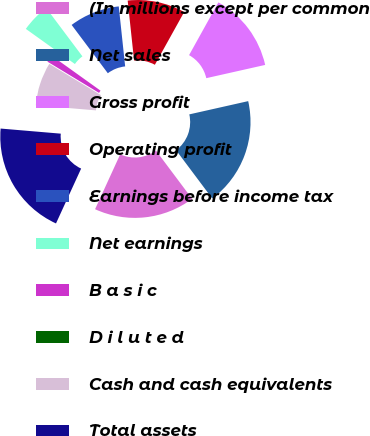<chart> <loc_0><loc_0><loc_500><loc_500><pie_chart><fcel>(In millions except per common<fcel>Net sales<fcel>Gross profit<fcel>Operating profit<fcel>Earnings before income tax<fcel>Net earnings<fcel>B a s i c<fcel>D i l u t e d<fcel>Cash and cash equivalents<fcel>Total assets<nl><fcel>17.07%<fcel>18.29%<fcel>13.41%<fcel>9.76%<fcel>8.54%<fcel>4.88%<fcel>1.22%<fcel>0.0%<fcel>7.32%<fcel>19.51%<nl></chart> 